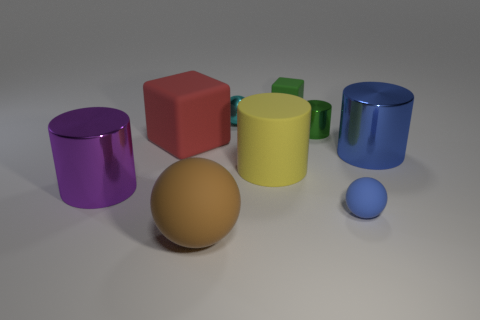Are there any blocks of the same color as the small shiny cylinder?
Offer a very short reply. Yes. There is a small ball right of the small metal object left of the small green block; what is its material?
Provide a short and direct response. Rubber. Is the cyan shiny object the same size as the green metallic thing?
Your answer should be compact. Yes. What number of objects are metal objects left of the blue rubber sphere or tiny matte things?
Provide a succinct answer. 5. There is a blue object that is in front of the big metallic thing to the right of the brown matte object; what shape is it?
Give a very brief answer. Sphere. Do the blue shiny cylinder and the metal cylinder on the left side of the red thing have the same size?
Provide a short and direct response. Yes. What is the small object in front of the big rubber cube made of?
Make the answer very short. Rubber. What number of cylinders are on the left side of the big red rubber thing and right of the small matte cube?
Offer a very short reply. 0. What material is the blue cylinder that is the same size as the yellow cylinder?
Make the answer very short. Metal. Does the sphere that is right of the yellow object have the same size as the matte cube that is in front of the small green rubber thing?
Keep it short and to the point. No. 